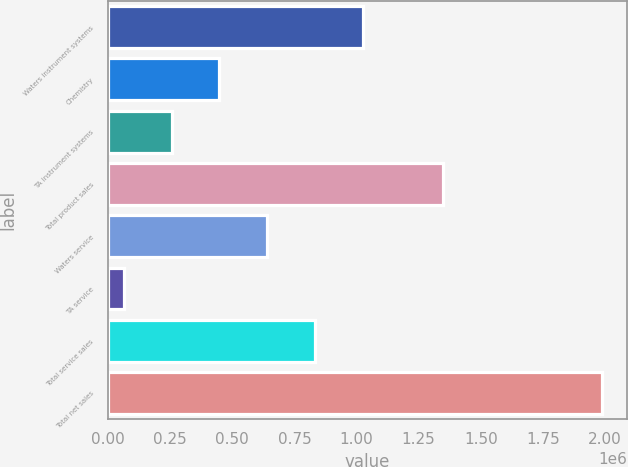Convert chart to OTSL. <chart><loc_0><loc_0><loc_500><loc_500><bar_chart><fcel>Waters instrument systems<fcel>Chemistry<fcel>TA instrument systems<fcel>Total product sales<fcel>Waters service<fcel>TA service<fcel>Total service sales<fcel>Total net sales<nl><fcel>1.0261e+06<fcel>448154<fcel>255505<fcel>1.34673e+06<fcel>640802<fcel>62856<fcel>833451<fcel>1.98934e+06<nl></chart> 